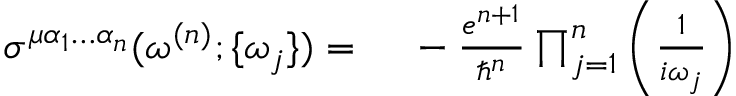<formula> <loc_0><loc_0><loc_500><loc_500>\begin{array} { r l } { \sigma ^ { \mu \alpha _ { 1 } \hdots \alpha _ { n } } ( \omega ^ { ( n ) } ; \{ \omega _ { j } \} ) = \, } & - \frac { e ^ { n + 1 } } { \hslash ^ { n } } \prod _ { j = 1 } ^ { n } \left ( \frac { 1 } { i \omega _ { j } } \right ) } \end{array}</formula> 